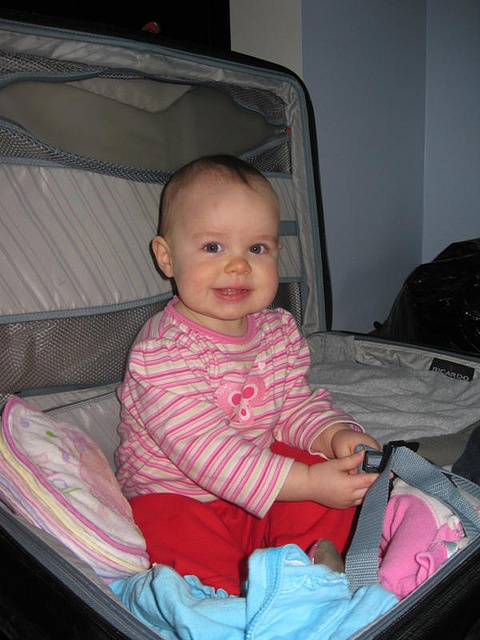Describe the objects in this image and their specific colors. I can see suitcase in black and gray tones and people in black, brown, lightpink, and salmon tones in this image. 